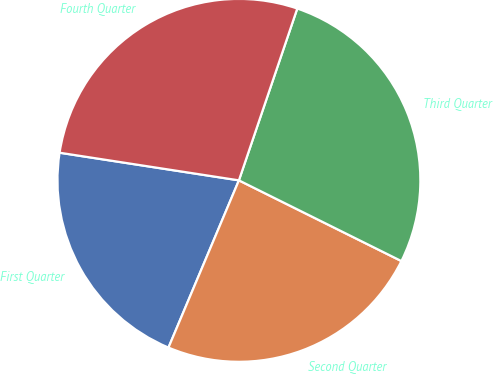<chart> <loc_0><loc_0><loc_500><loc_500><pie_chart><fcel>First Quarter<fcel>Second Quarter<fcel>Third Quarter<fcel>Fourth Quarter<nl><fcel>21.09%<fcel>24.01%<fcel>27.13%<fcel>27.78%<nl></chart> 